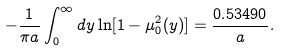<formula> <loc_0><loc_0><loc_500><loc_500>- \frac { 1 } { \pi a } \int _ { 0 } ^ { \infty } d y \ln [ 1 - \mu _ { 0 } ^ { 2 } ( y ) ] = \frac { 0 . 5 3 4 9 0 } { a } { . }</formula> 